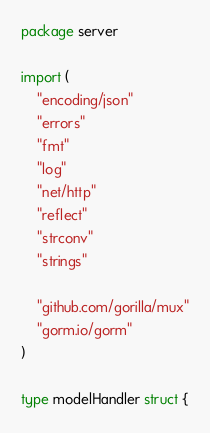Convert code to text. <code><loc_0><loc_0><loc_500><loc_500><_Go_>package server

import (
	"encoding/json"
	"errors"
	"fmt"
	"log"
	"net/http"
	"reflect"
	"strconv"
	"strings"

	"github.com/gorilla/mux"
	"gorm.io/gorm"
)

type modelHandler struct {</code> 